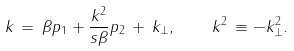<formula> <loc_0><loc_0><loc_500><loc_500>k \, = \, \beta p _ { 1 } + \frac { \boldmath k ^ { 2 } } { s \beta } p _ { 2 } \, + \, k _ { \perp } , \quad \boldmath k ^ { 2 } \, \equiv - k _ { \perp } ^ { 2 } .</formula> 